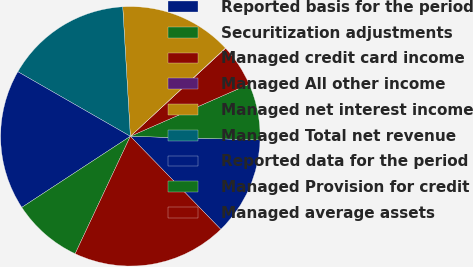<chart> <loc_0><loc_0><loc_500><loc_500><pie_chart><fcel>Reported basis for the period<fcel>Securitization adjustments<fcel>Managed credit card income<fcel>Managed All other income<fcel>Managed net interest income<fcel>Managed Total net revenue<fcel>Reported data for the period<fcel>Managed Provision for credit<fcel>Managed average assets<nl><fcel>12.28%<fcel>7.03%<fcel>5.29%<fcel>0.04%<fcel>14.02%<fcel>15.77%<fcel>17.52%<fcel>8.78%<fcel>19.27%<nl></chart> 